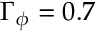<formula> <loc_0><loc_0><loc_500><loc_500>\Gamma _ { \phi } = 0 . 7</formula> 